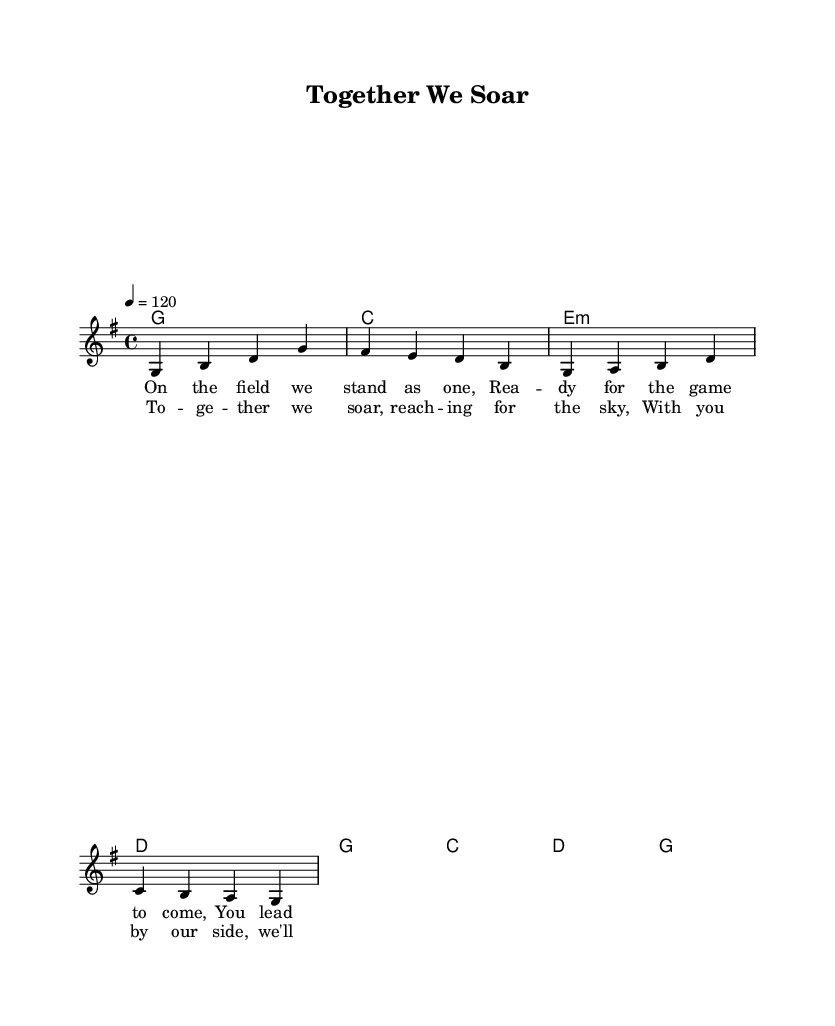What is the key signature of this music? The key signature is G major, as indicated by the presence of one sharp (F#) in the key signature section.
Answer: G major What is the time signature of this music? The time signature is indicated as 4/4, which shows that there are four beats per measure and the quarter note receives one beat.
Answer: 4/4 What is the tempo marking in this piece? The tempo marking is stated as "4 = 120," which specifies the speed at which the piece should be played, indicating 120 beats per minute.
Answer: 120 How many measures are in the melody? By counting the measures in the melody section, there are a total of four measures provided in this excerpt.
Answer: 4 What musical section comes after the verse? The structure provided indicates that after the verse, the next section is the chorus, which follows a common folk song format of verse-chorus.
Answer: Chorus What theme do the lyrics illustrate? The lyrics illustrate themes of teamwork and camaraderie, focusing on the idea of unity and support among team members in a game context.
Answer: Teamwork and camaraderie 